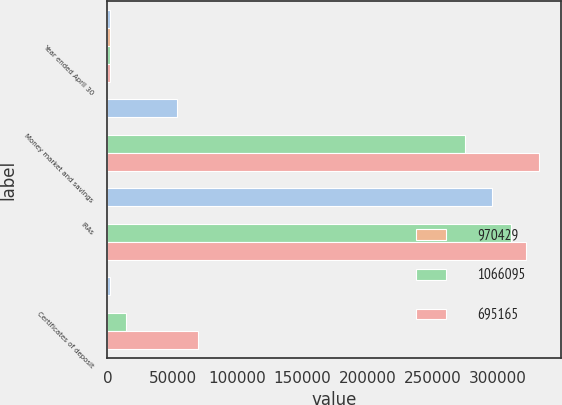Convert chart to OTSL. <chart><loc_0><loc_0><loc_500><loc_500><stacked_bar_chart><ecel><fcel>Year ended April 30<fcel>Money market and savings<fcel>IRAs<fcel>Certificates of deposit<nl><fcel>nan<fcel>2015<fcel>53402<fcel>296082<fcel>2060<nl><fcel>970429<fcel>2015<fcel>0.42<fcel>0.15<fcel>0.82<nl><fcel>1.0661e+06<fcel>2014<fcel>274633<fcel>310103<fcel>14006<nl><fcel>695165<fcel>2013<fcel>331819<fcel>322078<fcel>69444<nl></chart> 